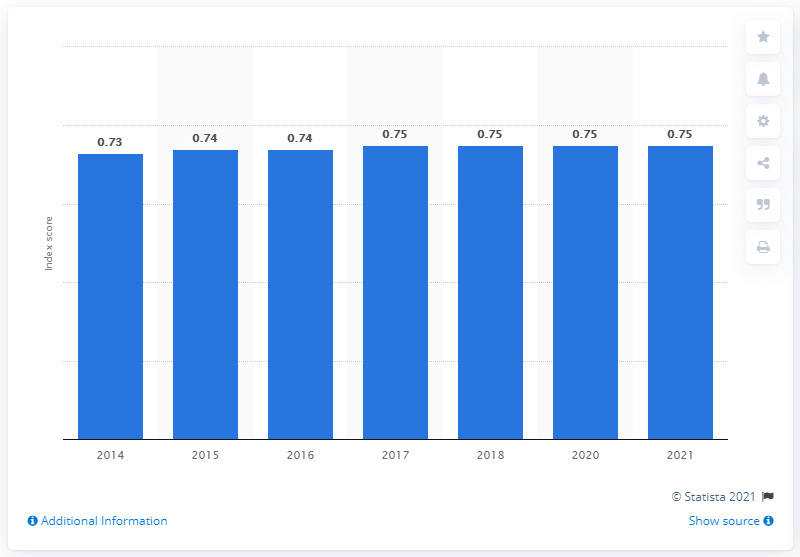Identify some key points in this picture. According to the gender gap index, Cuba has consistently scored 0.75 for four consecutive years, indicating a moderate gender equality in the country. 